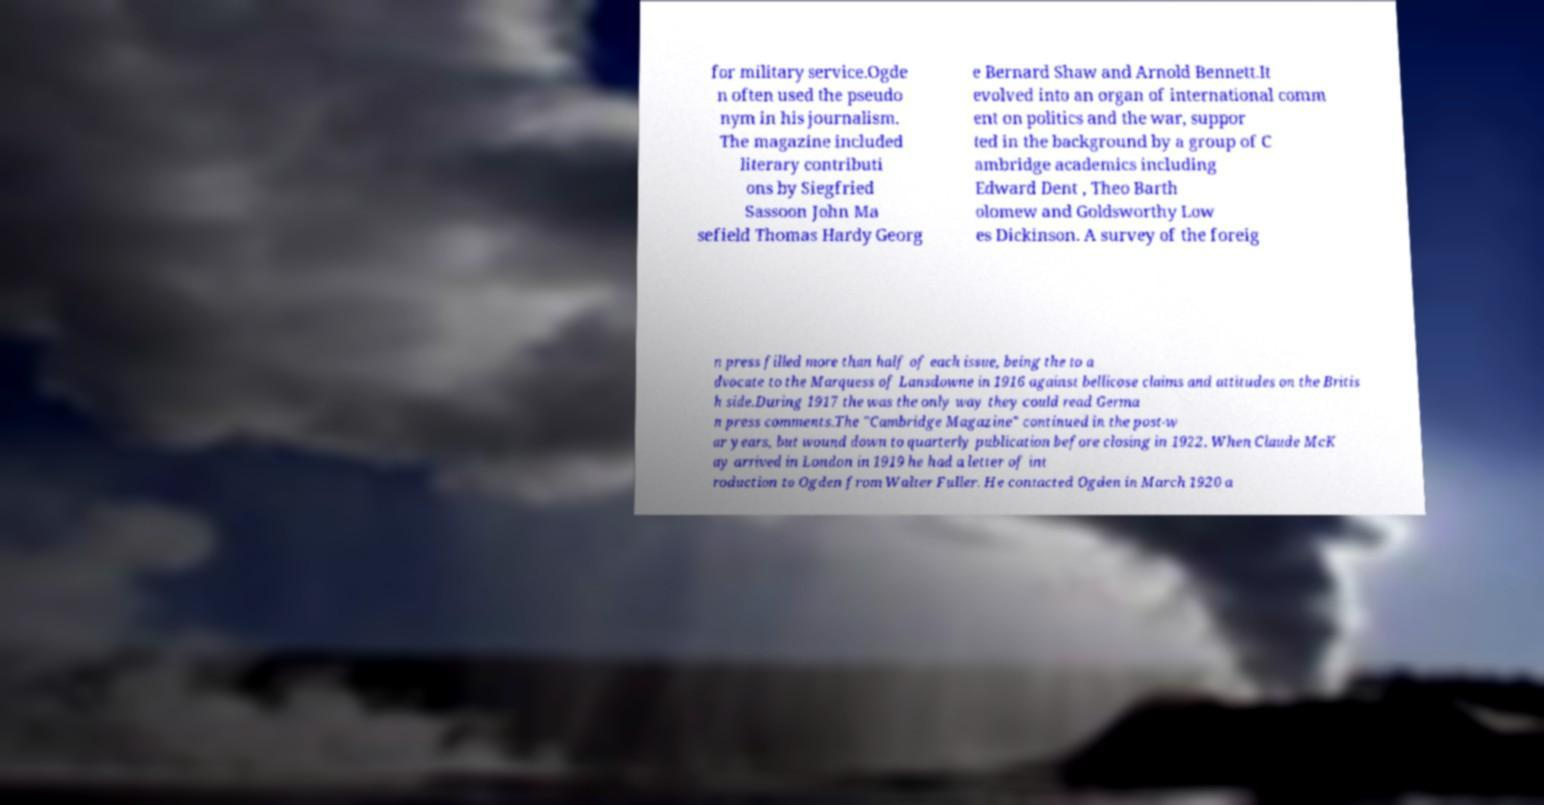What messages or text are displayed in this image? I need them in a readable, typed format. for military service.Ogde n often used the pseudo nym in his journalism. The magazine included literary contributi ons by Siegfried Sassoon John Ma sefield Thomas Hardy Georg e Bernard Shaw and Arnold Bennett.It evolved into an organ of international comm ent on politics and the war, suppor ted in the background by a group of C ambridge academics including Edward Dent , Theo Barth olomew and Goldsworthy Low es Dickinson. A survey of the foreig n press filled more than half of each issue, being the to a dvocate to the Marquess of Lansdowne in 1916 against bellicose claims and attitudes on the Britis h side.During 1917 the was the only way they could read Germa n press comments.The "Cambridge Magazine" continued in the post-w ar years, but wound down to quarterly publication before closing in 1922. When Claude McK ay arrived in London in 1919 he had a letter of int roduction to Ogden from Walter Fuller. He contacted Ogden in March 1920 a 